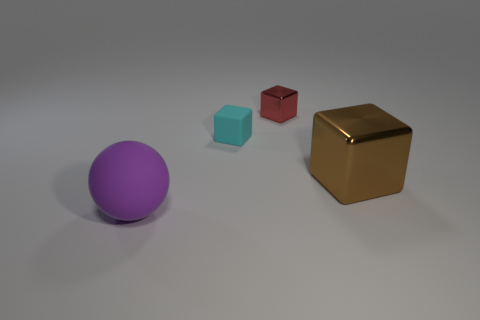Is the cube that is in front of the cyan rubber object made of the same material as the object that is behind the tiny cyan object?
Provide a succinct answer. Yes. The object that is both on the left side of the tiny metal object and in front of the small matte object has what shape?
Your response must be concise. Sphere. Is there any other thing that is made of the same material as the small red thing?
Your response must be concise. Yes. The object that is in front of the red object and behind the brown block is made of what material?
Your answer should be very brief. Rubber. There is a brown object that is made of the same material as the red block; what is its shape?
Ensure brevity in your answer.  Cube. Is there any other thing of the same color as the matte ball?
Your response must be concise. No. Is the number of big purple rubber objects behind the large purple matte object greater than the number of tiny cubes?
Provide a short and direct response. No. What material is the cyan block?
Provide a short and direct response. Rubber. How many red metallic cubes have the same size as the rubber block?
Give a very brief answer. 1. Is the number of tiny cyan things in front of the brown thing the same as the number of small red metallic blocks that are to the left of the purple rubber ball?
Ensure brevity in your answer.  Yes. 